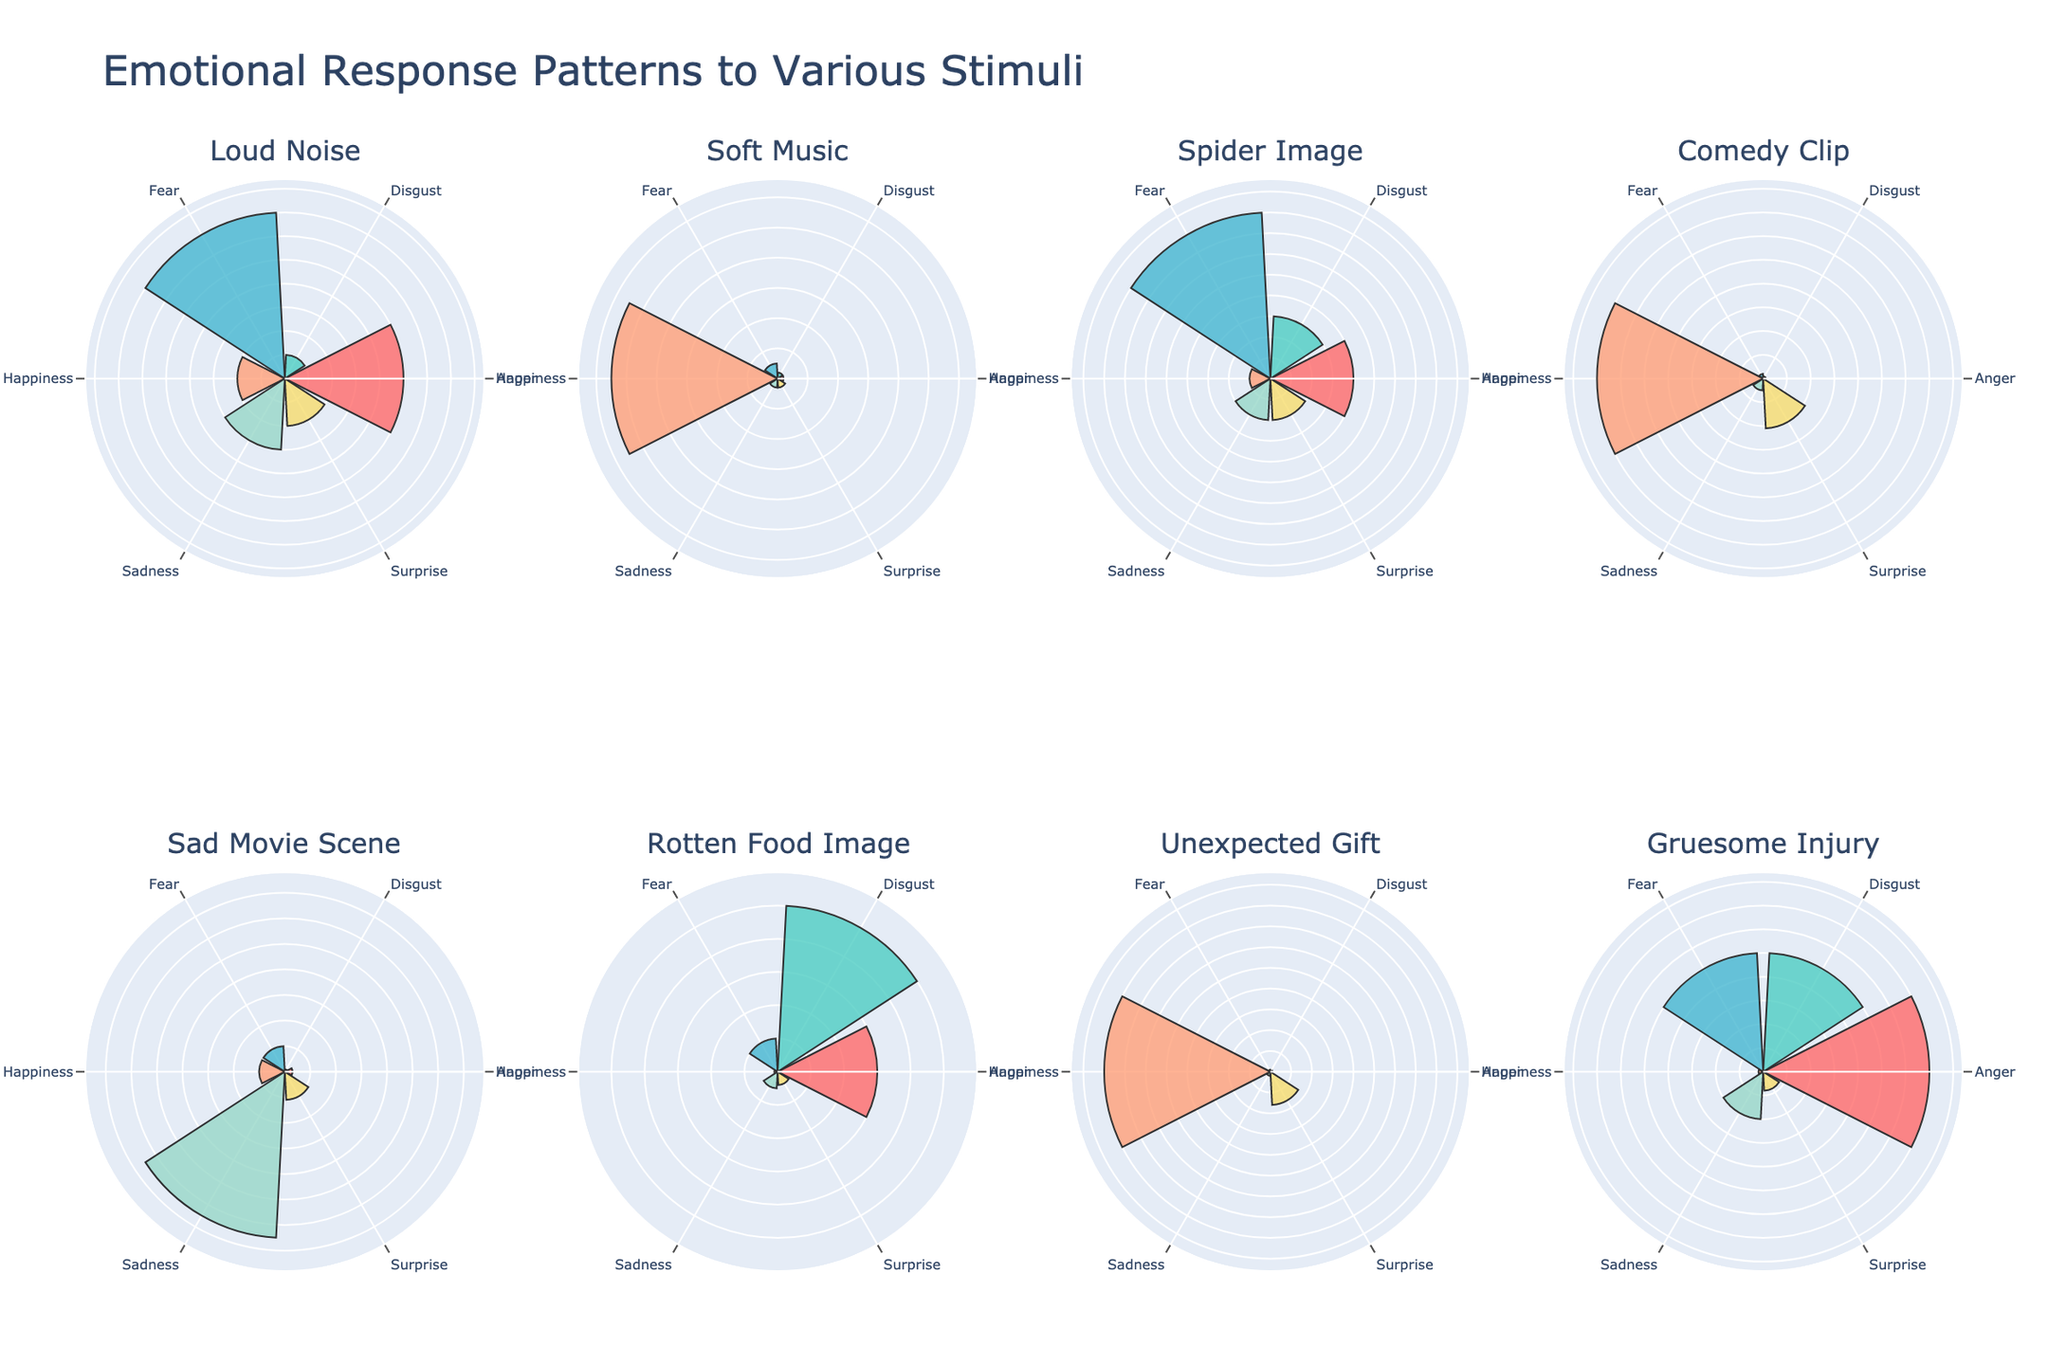What's the dominant emotional response for the Loud Noise stimulus? Observe the bar lengths in the Loud Noise subplot and identify the longest bar. The 'Fear' bar is the longest.
Answer: Fear Which stimulus triggered the highest amount of Happiness? Check the length of the Happiness bar across all subplots. The bar is longest for 'Unexpected Gift'.
Answer: Unexpected Gift Compare the Surprise response between Soft Music and Comedy Clip. Which one is higher? In the Soft Music subplot, the Surprise bar length is lower than that in the Comedy Clip subplot. The Comedy Clip has a higher Surprise response.
Answer: Comedy Clip What's the combined value of Anger and Disgust for the Rotten Food Image stimulus? Identify the individual values of Anger and Disgust for Rotten Food Image, which are 30 and 50 respectively. Sum these values: 30 + 50 = 80.
Answer: 80 What's unique about the emotional response to Soft Music compared to other stimuli? None of the other stimuli have Happiness as the dominant emotional response like Soft Music. The Happiness response is overwhelmingly higher than other emotions for Soft Music.
Answer: Happiness is dominant For which stimulus is Sadness the most significant emotional response? Check all subplots and see where the Sadness bar is the longest. It is the longest for 'Sad Movie Scene'.
Answer: Sad Movie Scene Among Loud Noise, Spider Image, and Gruesome Injury, which one has the highest Anger response? Compare the Anger bar lengths among these subplots. Gruesome Injury has the longest Anger bar.
Answer: Gruesome Injury On average, what is the Surprise response for all stimuli? Add the Surprise values for all stimuli and divide by the number of stimuli (10+3+10+21+11+4+16+4=79, 79/8=9.875).
Answer: 9.875 Which stimulus triggers a near-equal response between Anger and Fear? Compare the bar lengths for Anger and Fear in each subplot. The 'Gruesome Injury' has relatively similar lengths for Anger and Fear.
Answer: Gruesome Injury 